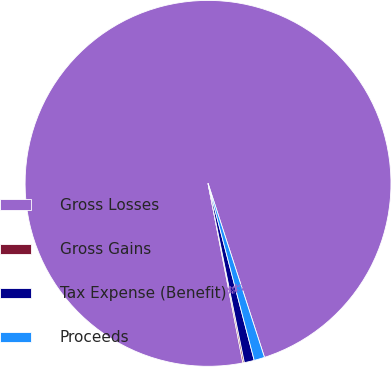Convert chart. <chart><loc_0><loc_0><loc_500><loc_500><pie_chart><fcel>Gross Losses<fcel>Gross Gains<fcel>Tax Expense (Benefit)<fcel>Proceeds<nl><fcel>98.06%<fcel>0.13%<fcel>0.88%<fcel>0.93%<nl></chart> 